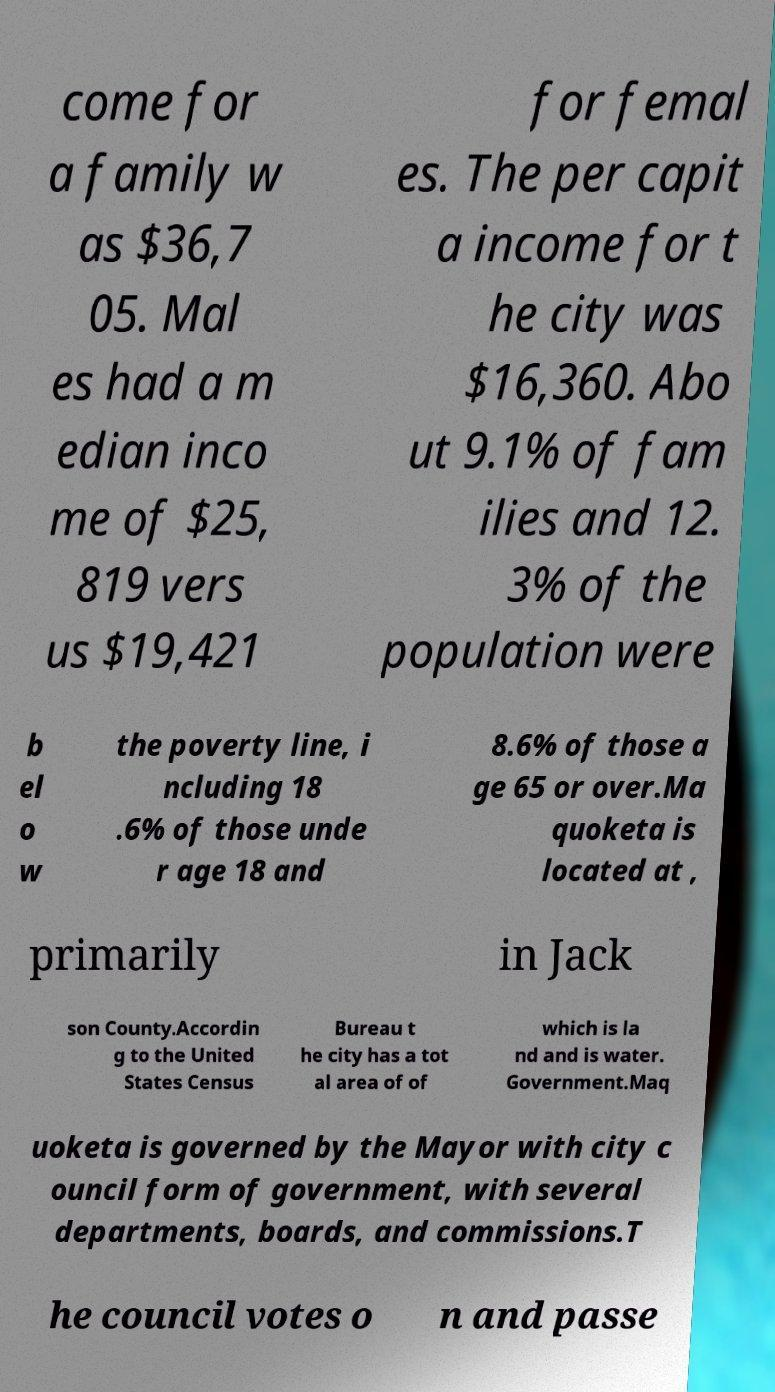Please identify and transcribe the text found in this image. come for a family w as $36,7 05. Mal es had a m edian inco me of $25, 819 vers us $19,421 for femal es. The per capit a income for t he city was $16,360. Abo ut 9.1% of fam ilies and 12. 3% of the population were b el o w the poverty line, i ncluding 18 .6% of those unde r age 18 and 8.6% of those a ge 65 or over.Ma quoketa is located at , primarily in Jack son County.Accordin g to the United States Census Bureau t he city has a tot al area of of which is la nd and is water. Government.Maq uoketa is governed by the Mayor with city c ouncil form of government, with several departments, boards, and commissions.T he council votes o n and passe 